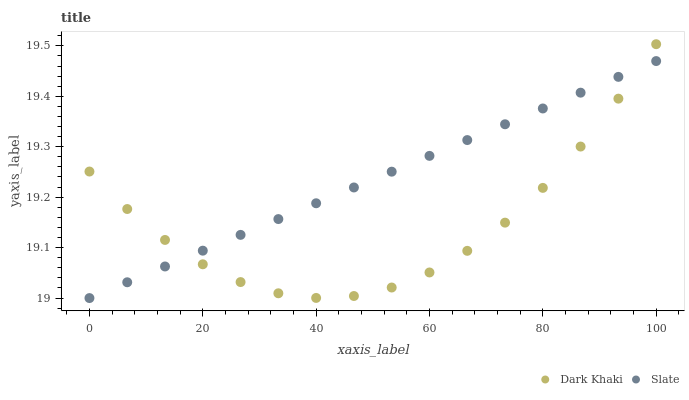Does Dark Khaki have the minimum area under the curve?
Answer yes or no. Yes. Does Slate have the maximum area under the curve?
Answer yes or no. Yes. Does Slate have the minimum area under the curve?
Answer yes or no. No. Is Slate the smoothest?
Answer yes or no. Yes. Is Dark Khaki the roughest?
Answer yes or no. Yes. Is Slate the roughest?
Answer yes or no. No. Does Slate have the lowest value?
Answer yes or no. Yes. Does Dark Khaki have the highest value?
Answer yes or no. Yes. Does Slate have the highest value?
Answer yes or no. No. Does Dark Khaki intersect Slate?
Answer yes or no. Yes. Is Dark Khaki less than Slate?
Answer yes or no. No. Is Dark Khaki greater than Slate?
Answer yes or no. No. 